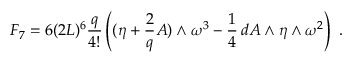<formula> <loc_0><loc_0><loc_500><loc_500>F _ { 7 } = 6 ( 2 L ) ^ { 6 } \frac { q } { 4 ! } \left ( ( \eta + \frac { 2 } { q } A ) \wedge \omega ^ { 3 } - \frac { 1 } { 4 } \, d A \wedge \eta \wedge \omega ^ { 2 } \right ) \ .</formula> 